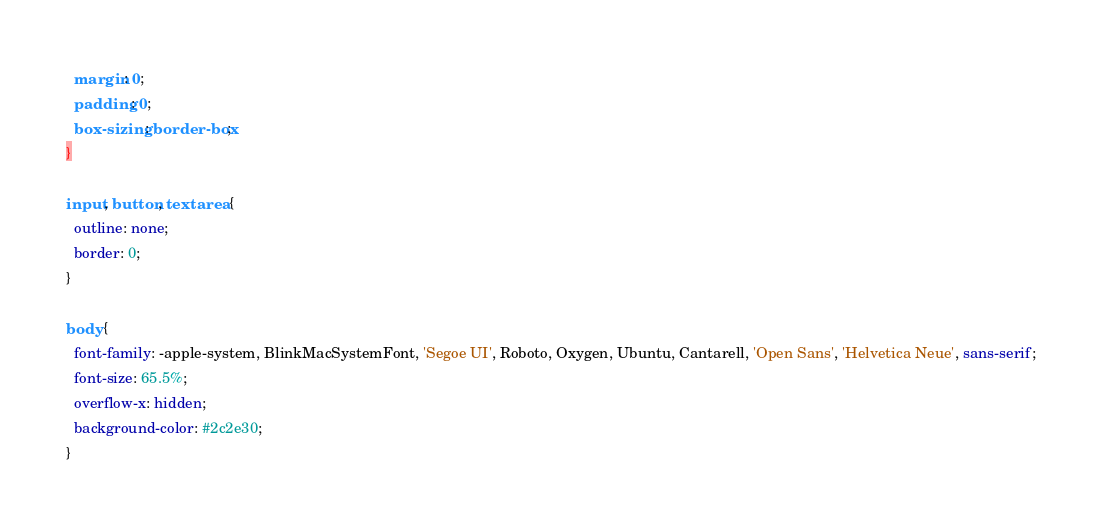Convert code to text. <code><loc_0><loc_0><loc_500><loc_500><_CSS_>  margin: 0;
  padding: 0;
  box-sizing: border-box;
}

input, button, textarea {
  outline: none;
  border: 0;
}

body {
  font-family: -apple-system, BlinkMacSystemFont, 'Segoe UI', Roboto, Oxygen, Ubuntu, Cantarell, 'Open Sans', 'Helvetica Neue', sans-serif;
  font-size: 65.5%;
  overflow-x: hidden;
  background-color: #2c2e30;
}</code> 